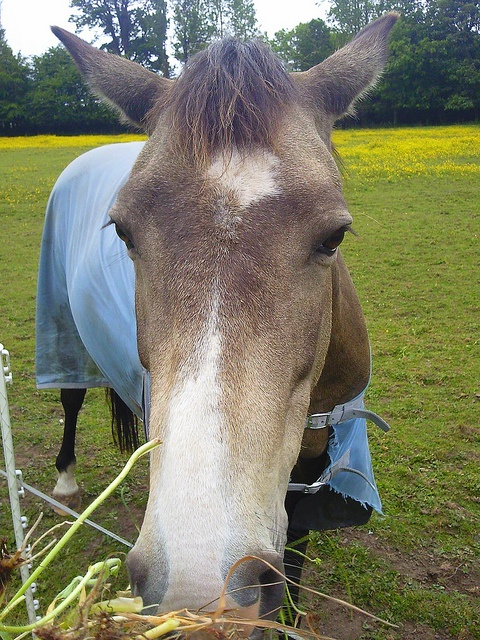Describe the objects in this image and their specific colors. I can see a horse in ivory, gray, darkgray, lightgray, and black tones in this image. 